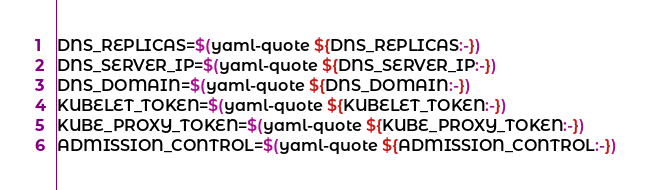<code> <loc_0><loc_0><loc_500><loc_500><_Bash_>DNS_REPLICAS=$(yaml-quote ${DNS_REPLICAS:-})
DNS_SERVER_IP=$(yaml-quote ${DNS_SERVER_IP:-})
DNS_DOMAIN=$(yaml-quote ${DNS_DOMAIN:-})
KUBELET_TOKEN=$(yaml-quote ${KUBELET_TOKEN:-})
KUBE_PROXY_TOKEN=$(yaml-quote ${KUBE_PROXY_TOKEN:-})
ADMISSION_CONTROL=$(yaml-quote ${ADMISSION_CONTROL:-})</code> 